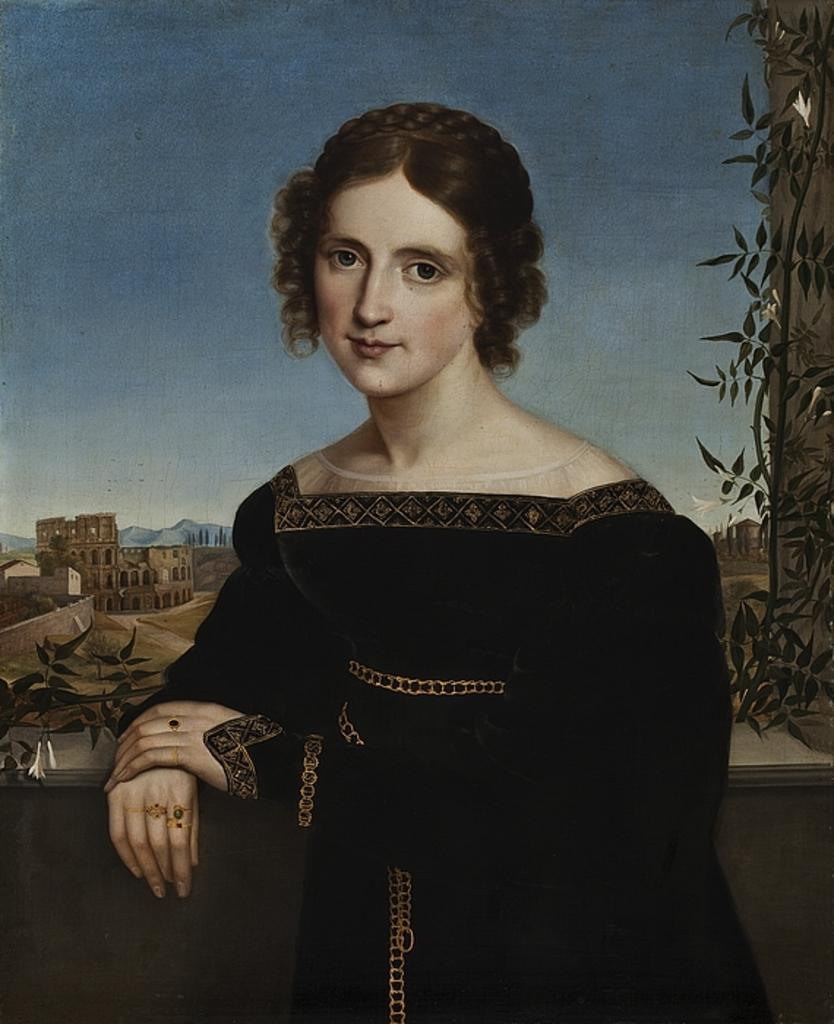Who is the main subject in the image? There is a woman in the image. What is the woman doing in the image? The woman is standing. What type of artwork is the image? The image is a painting. What is the woman wearing in the image? The woman is wearing a black dress. What can be seen in the background of the image? There is a building and the sky visible in the background of the image. Can you see a map in the woman's hand in the image? There is no map present in the image. Is there a rat visible near the woman's feet in the image? There is no rat present in the image. 